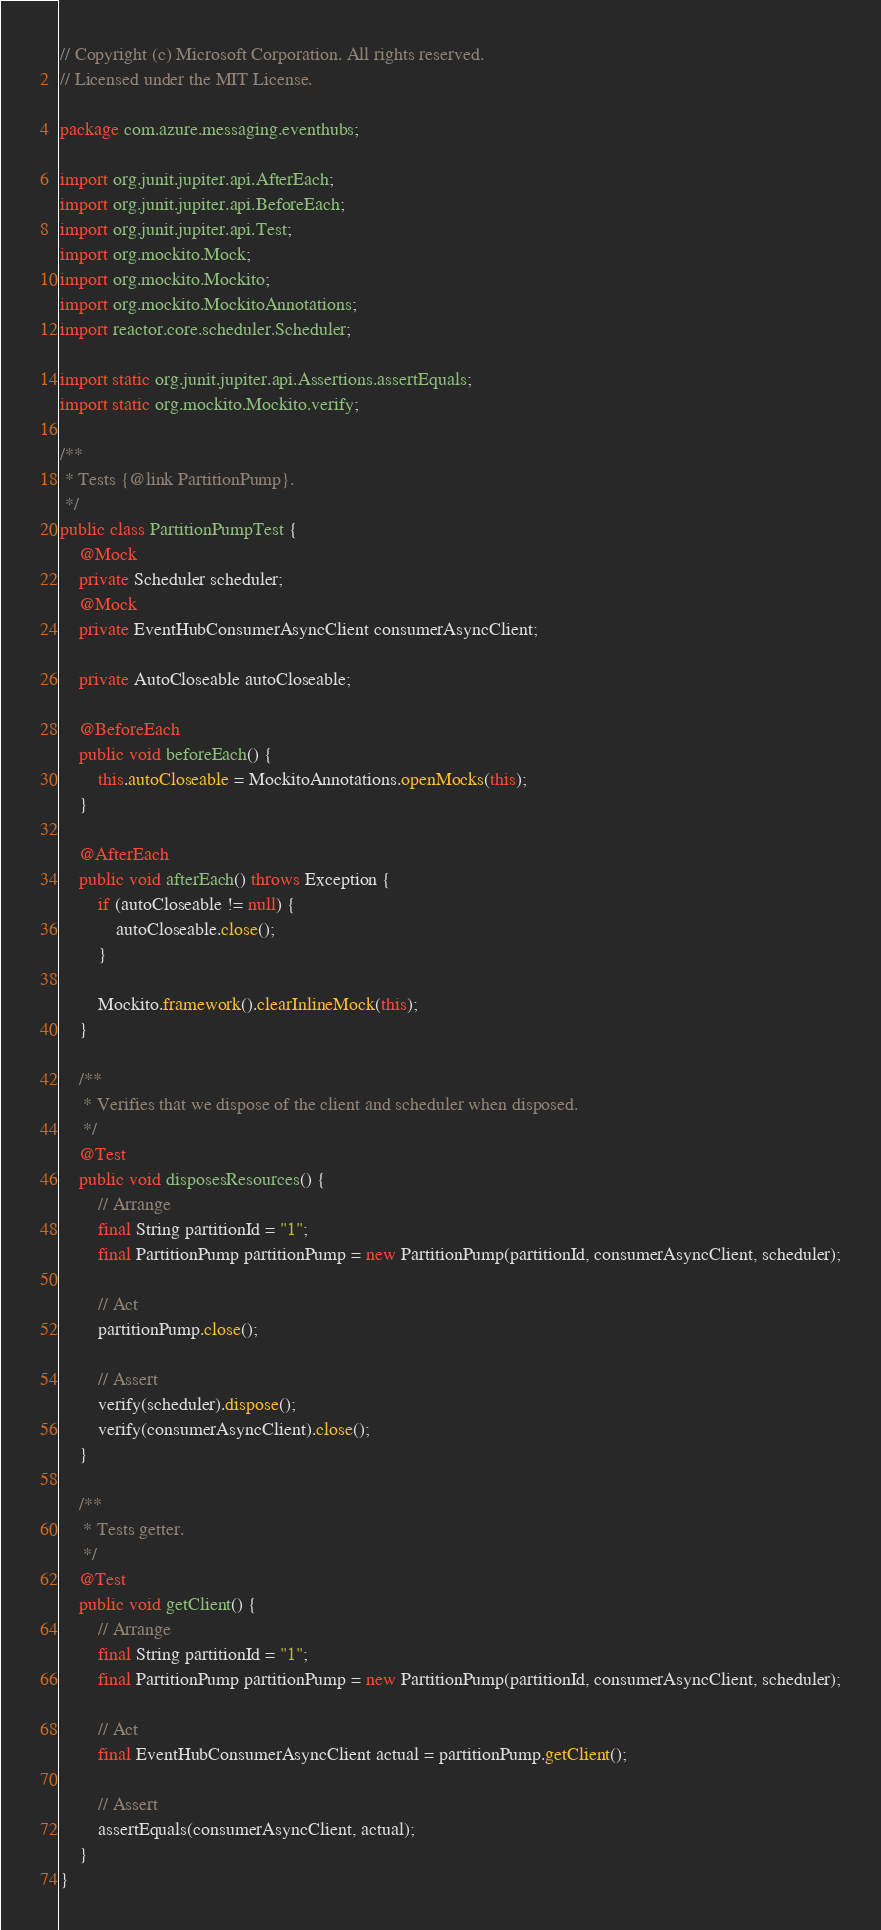<code> <loc_0><loc_0><loc_500><loc_500><_Java_>// Copyright (c) Microsoft Corporation. All rights reserved.
// Licensed under the MIT License.

package com.azure.messaging.eventhubs;

import org.junit.jupiter.api.AfterEach;
import org.junit.jupiter.api.BeforeEach;
import org.junit.jupiter.api.Test;
import org.mockito.Mock;
import org.mockito.Mockito;
import org.mockito.MockitoAnnotations;
import reactor.core.scheduler.Scheduler;

import static org.junit.jupiter.api.Assertions.assertEquals;
import static org.mockito.Mockito.verify;

/**
 * Tests {@link PartitionPump}.
 */
public class PartitionPumpTest {
    @Mock
    private Scheduler scheduler;
    @Mock
    private EventHubConsumerAsyncClient consumerAsyncClient;

    private AutoCloseable autoCloseable;

    @BeforeEach
    public void beforeEach() {
        this.autoCloseable = MockitoAnnotations.openMocks(this);
    }

    @AfterEach
    public void afterEach() throws Exception {
        if (autoCloseable != null) {
            autoCloseable.close();
        }

        Mockito.framework().clearInlineMock(this);
    }

    /**
     * Verifies that we dispose of the client and scheduler when disposed.
     */
    @Test
    public void disposesResources() {
        // Arrange
        final String partitionId = "1";
        final PartitionPump partitionPump = new PartitionPump(partitionId, consumerAsyncClient, scheduler);

        // Act
        partitionPump.close();

        // Assert
        verify(scheduler).dispose();
        verify(consumerAsyncClient).close();
    }

    /**
     * Tests getter.
     */
    @Test
    public void getClient() {
        // Arrange
        final String partitionId = "1";
        final PartitionPump partitionPump = new PartitionPump(partitionId, consumerAsyncClient, scheduler);

        // Act
        final EventHubConsumerAsyncClient actual = partitionPump.getClient();

        // Assert
        assertEquals(consumerAsyncClient, actual);
    }
}
</code> 